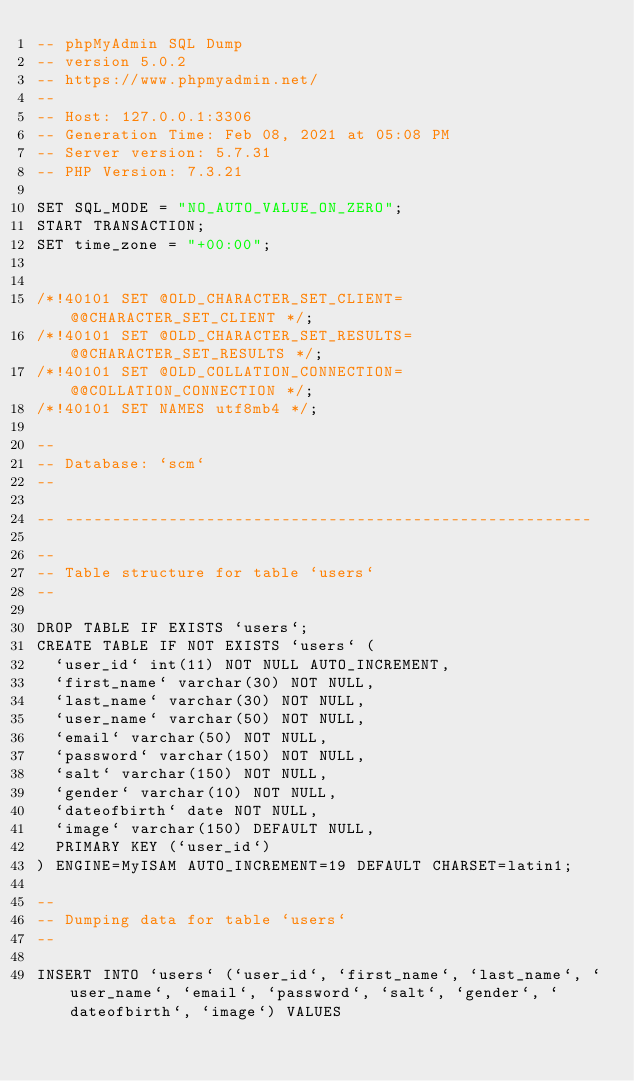Convert code to text. <code><loc_0><loc_0><loc_500><loc_500><_SQL_>-- phpMyAdmin SQL Dump
-- version 5.0.2
-- https://www.phpmyadmin.net/
--
-- Host: 127.0.0.1:3306
-- Generation Time: Feb 08, 2021 at 05:08 PM
-- Server version: 5.7.31
-- PHP Version: 7.3.21

SET SQL_MODE = "NO_AUTO_VALUE_ON_ZERO";
START TRANSACTION;
SET time_zone = "+00:00";


/*!40101 SET @OLD_CHARACTER_SET_CLIENT=@@CHARACTER_SET_CLIENT */;
/*!40101 SET @OLD_CHARACTER_SET_RESULTS=@@CHARACTER_SET_RESULTS */;
/*!40101 SET @OLD_COLLATION_CONNECTION=@@COLLATION_CONNECTION */;
/*!40101 SET NAMES utf8mb4 */;

--
-- Database: `scm`
--

-- --------------------------------------------------------

--
-- Table structure for table `users`
--

DROP TABLE IF EXISTS `users`;
CREATE TABLE IF NOT EXISTS `users` (
  `user_id` int(11) NOT NULL AUTO_INCREMENT,
  `first_name` varchar(30) NOT NULL,
  `last_name` varchar(30) NOT NULL,
  `user_name` varchar(50) NOT NULL,
  `email` varchar(50) NOT NULL,
  `password` varchar(150) NOT NULL,
  `salt` varchar(150) NOT NULL,
  `gender` varchar(10) NOT NULL,
  `dateofbirth` date NOT NULL,
  `image` varchar(150) DEFAULT NULL,
  PRIMARY KEY (`user_id`)
) ENGINE=MyISAM AUTO_INCREMENT=19 DEFAULT CHARSET=latin1;

--
-- Dumping data for table `users`
--

INSERT INTO `users` (`user_id`, `first_name`, `last_name`, `user_name`, `email`, `password`, `salt`, `gender`, `dateofbirth`, `image`) VALUES</code> 